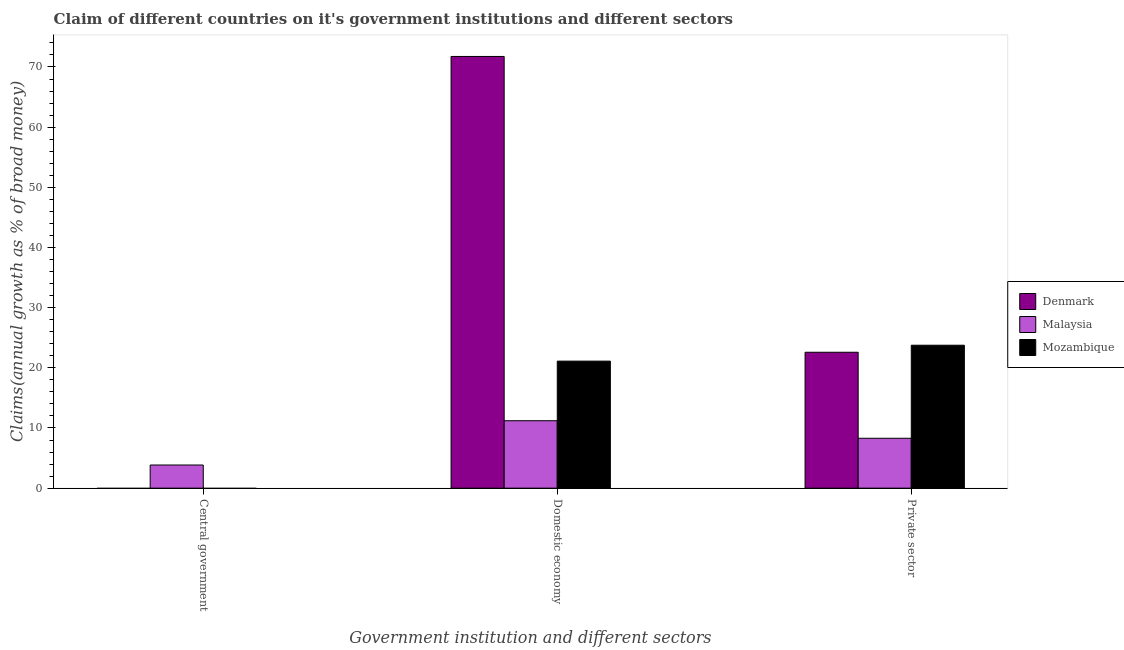Are the number of bars per tick equal to the number of legend labels?
Make the answer very short. No. Are the number of bars on each tick of the X-axis equal?
Provide a short and direct response. No. How many bars are there on the 2nd tick from the left?
Offer a very short reply. 3. How many bars are there on the 2nd tick from the right?
Provide a succinct answer. 3. What is the label of the 3rd group of bars from the left?
Make the answer very short. Private sector. What is the percentage of claim on the domestic economy in Mozambique?
Offer a very short reply. 21.11. Across all countries, what is the maximum percentage of claim on the domestic economy?
Offer a very short reply. 71.75. Across all countries, what is the minimum percentage of claim on the domestic economy?
Keep it short and to the point. 11.21. In which country was the percentage of claim on the central government maximum?
Give a very brief answer. Malaysia. What is the total percentage of claim on the domestic economy in the graph?
Make the answer very short. 104.07. What is the difference between the percentage of claim on the private sector in Malaysia and that in Denmark?
Offer a very short reply. -14.3. What is the difference between the percentage of claim on the central government in Mozambique and the percentage of claim on the private sector in Malaysia?
Offer a very short reply. -8.29. What is the average percentage of claim on the domestic economy per country?
Your response must be concise. 34.69. What is the difference between the percentage of claim on the private sector and percentage of claim on the central government in Malaysia?
Provide a short and direct response. 4.44. What is the ratio of the percentage of claim on the domestic economy in Mozambique to that in Denmark?
Your response must be concise. 0.29. Is the percentage of claim on the domestic economy in Denmark less than that in Mozambique?
Your answer should be compact. No. What is the difference between the highest and the second highest percentage of claim on the private sector?
Your answer should be compact. 1.17. What is the difference between the highest and the lowest percentage of claim on the central government?
Provide a succinct answer. 3.85. In how many countries, is the percentage of claim on the central government greater than the average percentage of claim on the central government taken over all countries?
Provide a short and direct response. 1. How many bars are there?
Give a very brief answer. 7. Are all the bars in the graph horizontal?
Your answer should be compact. No. Are the values on the major ticks of Y-axis written in scientific E-notation?
Offer a terse response. No. Does the graph contain any zero values?
Your response must be concise. Yes. Where does the legend appear in the graph?
Your answer should be compact. Center right. How are the legend labels stacked?
Your answer should be very brief. Vertical. What is the title of the graph?
Give a very brief answer. Claim of different countries on it's government institutions and different sectors. What is the label or title of the X-axis?
Offer a very short reply. Government institution and different sectors. What is the label or title of the Y-axis?
Offer a terse response. Claims(annual growth as % of broad money). What is the Claims(annual growth as % of broad money) of Denmark in Central government?
Your answer should be compact. 0. What is the Claims(annual growth as % of broad money) in Malaysia in Central government?
Ensure brevity in your answer.  3.85. What is the Claims(annual growth as % of broad money) of Mozambique in Central government?
Give a very brief answer. 0. What is the Claims(annual growth as % of broad money) of Denmark in Domestic economy?
Your response must be concise. 71.75. What is the Claims(annual growth as % of broad money) in Malaysia in Domestic economy?
Your answer should be compact. 11.21. What is the Claims(annual growth as % of broad money) of Mozambique in Domestic economy?
Offer a very short reply. 21.11. What is the Claims(annual growth as % of broad money) of Denmark in Private sector?
Offer a terse response. 22.59. What is the Claims(annual growth as % of broad money) of Malaysia in Private sector?
Offer a terse response. 8.29. What is the Claims(annual growth as % of broad money) of Mozambique in Private sector?
Your answer should be very brief. 23.76. Across all Government institution and different sectors, what is the maximum Claims(annual growth as % of broad money) of Denmark?
Make the answer very short. 71.75. Across all Government institution and different sectors, what is the maximum Claims(annual growth as % of broad money) of Malaysia?
Give a very brief answer. 11.21. Across all Government institution and different sectors, what is the maximum Claims(annual growth as % of broad money) of Mozambique?
Give a very brief answer. 23.76. Across all Government institution and different sectors, what is the minimum Claims(annual growth as % of broad money) of Malaysia?
Provide a short and direct response. 3.85. What is the total Claims(annual growth as % of broad money) in Denmark in the graph?
Your response must be concise. 94.33. What is the total Claims(annual growth as % of broad money) of Malaysia in the graph?
Keep it short and to the point. 23.34. What is the total Claims(annual growth as % of broad money) in Mozambique in the graph?
Provide a succinct answer. 44.87. What is the difference between the Claims(annual growth as % of broad money) of Malaysia in Central government and that in Domestic economy?
Ensure brevity in your answer.  -7.36. What is the difference between the Claims(annual growth as % of broad money) in Malaysia in Central government and that in Private sector?
Your answer should be compact. -4.44. What is the difference between the Claims(annual growth as % of broad money) in Denmark in Domestic economy and that in Private sector?
Your answer should be very brief. 49.16. What is the difference between the Claims(annual growth as % of broad money) in Malaysia in Domestic economy and that in Private sector?
Your answer should be compact. 2.92. What is the difference between the Claims(annual growth as % of broad money) of Mozambique in Domestic economy and that in Private sector?
Make the answer very short. -2.65. What is the difference between the Claims(annual growth as % of broad money) in Malaysia in Central government and the Claims(annual growth as % of broad money) in Mozambique in Domestic economy?
Give a very brief answer. -17.26. What is the difference between the Claims(annual growth as % of broad money) of Malaysia in Central government and the Claims(annual growth as % of broad money) of Mozambique in Private sector?
Provide a succinct answer. -19.91. What is the difference between the Claims(annual growth as % of broad money) of Denmark in Domestic economy and the Claims(annual growth as % of broad money) of Malaysia in Private sector?
Offer a terse response. 63.46. What is the difference between the Claims(annual growth as % of broad money) of Denmark in Domestic economy and the Claims(annual growth as % of broad money) of Mozambique in Private sector?
Provide a short and direct response. 47.99. What is the difference between the Claims(annual growth as % of broad money) in Malaysia in Domestic economy and the Claims(annual growth as % of broad money) in Mozambique in Private sector?
Make the answer very short. -12.55. What is the average Claims(annual growth as % of broad money) in Denmark per Government institution and different sectors?
Your answer should be very brief. 31.44. What is the average Claims(annual growth as % of broad money) in Malaysia per Government institution and different sectors?
Provide a succinct answer. 7.78. What is the average Claims(annual growth as % of broad money) in Mozambique per Government institution and different sectors?
Your response must be concise. 14.96. What is the difference between the Claims(annual growth as % of broad money) in Denmark and Claims(annual growth as % of broad money) in Malaysia in Domestic economy?
Your response must be concise. 60.54. What is the difference between the Claims(annual growth as % of broad money) of Denmark and Claims(annual growth as % of broad money) of Mozambique in Domestic economy?
Offer a terse response. 50.64. What is the difference between the Claims(annual growth as % of broad money) in Malaysia and Claims(annual growth as % of broad money) in Mozambique in Domestic economy?
Make the answer very short. -9.9. What is the difference between the Claims(annual growth as % of broad money) in Denmark and Claims(annual growth as % of broad money) in Malaysia in Private sector?
Keep it short and to the point. 14.3. What is the difference between the Claims(annual growth as % of broad money) of Denmark and Claims(annual growth as % of broad money) of Mozambique in Private sector?
Keep it short and to the point. -1.17. What is the difference between the Claims(annual growth as % of broad money) in Malaysia and Claims(annual growth as % of broad money) in Mozambique in Private sector?
Your response must be concise. -15.47. What is the ratio of the Claims(annual growth as % of broad money) in Malaysia in Central government to that in Domestic economy?
Provide a short and direct response. 0.34. What is the ratio of the Claims(annual growth as % of broad money) in Malaysia in Central government to that in Private sector?
Provide a short and direct response. 0.46. What is the ratio of the Claims(annual growth as % of broad money) in Denmark in Domestic economy to that in Private sector?
Offer a very short reply. 3.18. What is the ratio of the Claims(annual growth as % of broad money) in Malaysia in Domestic economy to that in Private sector?
Give a very brief answer. 1.35. What is the ratio of the Claims(annual growth as % of broad money) of Mozambique in Domestic economy to that in Private sector?
Your answer should be very brief. 0.89. What is the difference between the highest and the second highest Claims(annual growth as % of broad money) of Malaysia?
Give a very brief answer. 2.92. What is the difference between the highest and the lowest Claims(annual growth as % of broad money) of Denmark?
Make the answer very short. 71.75. What is the difference between the highest and the lowest Claims(annual growth as % of broad money) in Malaysia?
Make the answer very short. 7.36. What is the difference between the highest and the lowest Claims(annual growth as % of broad money) in Mozambique?
Offer a terse response. 23.76. 